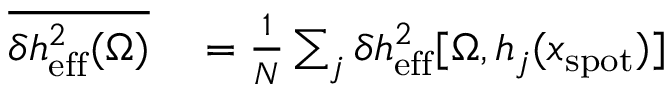Convert formula to latex. <formula><loc_0><loc_0><loc_500><loc_500>\begin{array} { r l } { \overline { { \delta h _ { e f f } ^ { 2 } ( \Omega ) } } } & = \frac { 1 } { N } \sum _ { j } \delta h _ { e f f } ^ { 2 } [ \Omega , h _ { j } ( x _ { s p o t } ) ] } \end{array}</formula> 